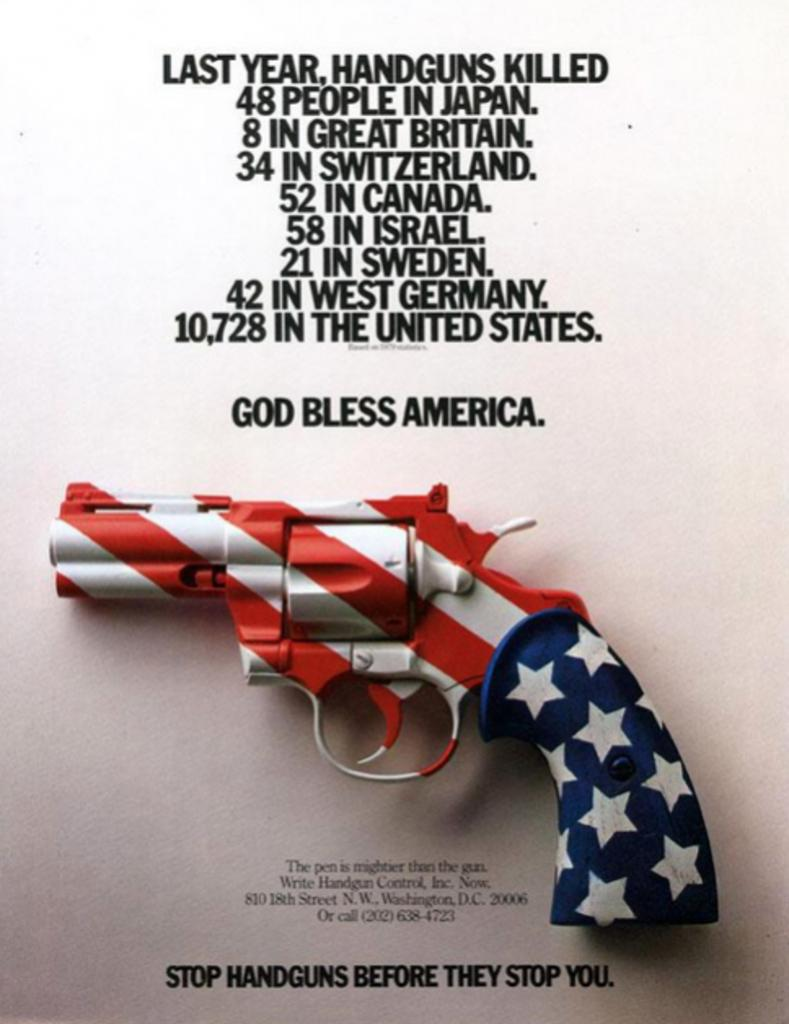What is the main object in the picture? There is a revolver in the picture. What colors can be seen on the revolver? The revolver has blue, white, and red colors. Is there any text present in the image? Yes, there is text in the picture. What color is the background of the image? The background of the image is white. Can you see a shelf in the image? There is no shelf present in the image. 